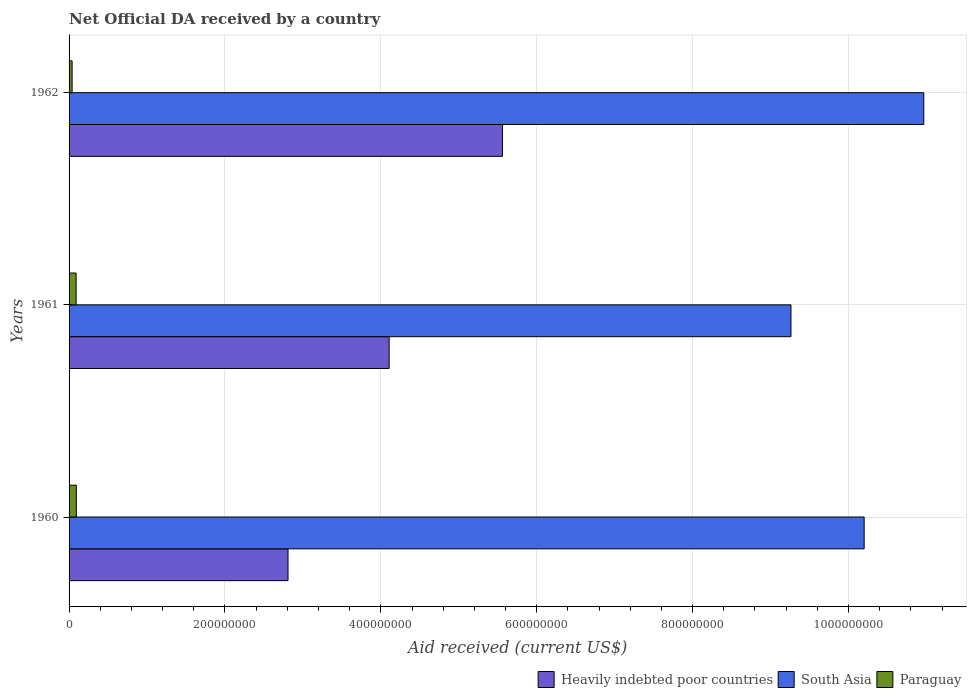How many groups of bars are there?
Offer a very short reply. 3. Are the number of bars per tick equal to the number of legend labels?
Make the answer very short. Yes. Are the number of bars on each tick of the Y-axis equal?
Provide a short and direct response. Yes. How many bars are there on the 3rd tick from the top?
Provide a succinct answer. 3. How many bars are there on the 1st tick from the bottom?
Keep it short and to the point. 3. In how many cases, is the number of bars for a given year not equal to the number of legend labels?
Offer a very short reply. 0. What is the net official development assistance aid received in Paraguay in 1961?
Provide a succinct answer. 9.07e+06. Across all years, what is the maximum net official development assistance aid received in Paraguay?
Make the answer very short. 9.32e+06. Across all years, what is the minimum net official development assistance aid received in South Asia?
Make the answer very short. 9.26e+08. In which year was the net official development assistance aid received in Heavily indebted poor countries maximum?
Your answer should be very brief. 1962. What is the total net official development assistance aid received in Heavily indebted poor countries in the graph?
Provide a short and direct response. 1.25e+09. What is the difference between the net official development assistance aid received in Paraguay in 1960 and that in 1962?
Provide a short and direct response. 5.43e+06. What is the difference between the net official development assistance aid received in Heavily indebted poor countries in 1961 and the net official development assistance aid received in South Asia in 1960?
Ensure brevity in your answer.  -6.09e+08. What is the average net official development assistance aid received in Heavily indebted poor countries per year?
Keep it short and to the point. 4.16e+08. In the year 1961, what is the difference between the net official development assistance aid received in Heavily indebted poor countries and net official development assistance aid received in South Asia?
Ensure brevity in your answer.  -5.16e+08. What is the ratio of the net official development assistance aid received in South Asia in 1960 to that in 1962?
Your response must be concise. 0.93. Is the net official development assistance aid received in Paraguay in 1960 less than that in 1961?
Provide a succinct answer. No. What is the difference between the highest and the second highest net official development assistance aid received in Heavily indebted poor countries?
Ensure brevity in your answer.  1.45e+08. What is the difference between the highest and the lowest net official development assistance aid received in South Asia?
Your answer should be very brief. 1.70e+08. In how many years, is the net official development assistance aid received in Paraguay greater than the average net official development assistance aid received in Paraguay taken over all years?
Ensure brevity in your answer.  2. What does the 1st bar from the bottom in 1961 represents?
Ensure brevity in your answer.  Heavily indebted poor countries. Is it the case that in every year, the sum of the net official development assistance aid received in Paraguay and net official development assistance aid received in Heavily indebted poor countries is greater than the net official development assistance aid received in South Asia?
Give a very brief answer. No. How many bars are there?
Provide a succinct answer. 9. Are the values on the major ticks of X-axis written in scientific E-notation?
Keep it short and to the point. No. Does the graph contain any zero values?
Your answer should be compact. No. What is the title of the graph?
Your response must be concise. Net Official DA received by a country. Does "St. Kitts and Nevis" appear as one of the legend labels in the graph?
Provide a succinct answer. No. What is the label or title of the X-axis?
Make the answer very short. Aid received (current US$). What is the Aid received (current US$) of Heavily indebted poor countries in 1960?
Your answer should be compact. 2.81e+08. What is the Aid received (current US$) in South Asia in 1960?
Provide a short and direct response. 1.02e+09. What is the Aid received (current US$) of Paraguay in 1960?
Make the answer very short. 9.32e+06. What is the Aid received (current US$) of Heavily indebted poor countries in 1961?
Your answer should be compact. 4.11e+08. What is the Aid received (current US$) of South Asia in 1961?
Offer a terse response. 9.26e+08. What is the Aid received (current US$) in Paraguay in 1961?
Your response must be concise. 9.07e+06. What is the Aid received (current US$) of Heavily indebted poor countries in 1962?
Your response must be concise. 5.56e+08. What is the Aid received (current US$) of South Asia in 1962?
Give a very brief answer. 1.10e+09. What is the Aid received (current US$) in Paraguay in 1962?
Provide a short and direct response. 3.89e+06. Across all years, what is the maximum Aid received (current US$) in Heavily indebted poor countries?
Your answer should be compact. 5.56e+08. Across all years, what is the maximum Aid received (current US$) of South Asia?
Your answer should be very brief. 1.10e+09. Across all years, what is the maximum Aid received (current US$) in Paraguay?
Your answer should be compact. 9.32e+06. Across all years, what is the minimum Aid received (current US$) of Heavily indebted poor countries?
Your response must be concise. 2.81e+08. Across all years, what is the minimum Aid received (current US$) in South Asia?
Your answer should be compact. 9.26e+08. Across all years, what is the minimum Aid received (current US$) in Paraguay?
Give a very brief answer. 3.89e+06. What is the total Aid received (current US$) in Heavily indebted poor countries in the graph?
Your answer should be compact. 1.25e+09. What is the total Aid received (current US$) of South Asia in the graph?
Keep it short and to the point. 3.04e+09. What is the total Aid received (current US$) in Paraguay in the graph?
Offer a very short reply. 2.23e+07. What is the difference between the Aid received (current US$) in Heavily indebted poor countries in 1960 and that in 1961?
Provide a succinct answer. -1.30e+08. What is the difference between the Aid received (current US$) in South Asia in 1960 and that in 1961?
Your answer should be compact. 9.39e+07. What is the difference between the Aid received (current US$) of Paraguay in 1960 and that in 1961?
Give a very brief answer. 2.50e+05. What is the difference between the Aid received (current US$) in Heavily indebted poor countries in 1960 and that in 1962?
Give a very brief answer. -2.75e+08. What is the difference between the Aid received (current US$) in South Asia in 1960 and that in 1962?
Give a very brief answer. -7.65e+07. What is the difference between the Aid received (current US$) of Paraguay in 1960 and that in 1962?
Give a very brief answer. 5.43e+06. What is the difference between the Aid received (current US$) in Heavily indebted poor countries in 1961 and that in 1962?
Your answer should be compact. -1.45e+08. What is the difference between the Aid received (current US$) of South Asia in 1961 and that in 1962?
Make the answer very short. -1.70e+08. What is the difference between the Aid received (current US$) of Paraguay in 1961 and that in 1962?
Provide a succinct answer. 5.18e+06. What is the difference between the Aid received (current US$) in Heavily indebted poor countries in 1960 and the Aid received (current US$) in South Asia in 1961?
Keep it short and to the point. -6.45e+08. What is the difference between the Aid received (current US$) in Heavily indebted poor countries in 1960 and the Aid received (current US$) in Paraguay in 1961?
Your answer should be very brief. 2.72e+08. What is the difference between the Aid received (current US$) in South Asia in 1960 and the Aid received (current US$) in Paraguay in 1961?
Your response must be concise. 1.01e+09. What is the difference between the Aid received (current US$) of Heavily indebted poor countries in 1960 and the Aid received (current US$) of South Asia in 1962?
Your response must be concise. -8.16e+08. What is the difference between the Aid received (current US$) in Heavily indebted poor countries in 1960 and the Aid received (current US$) in Paraguay in 1962?
Your answer should be very brief. 2.77e+08. What is the difference between the Aid received (current US$) of South Asia in 1960 and the Aid received (current US$) of Paraguay in 1962?
Give a very brief answer. 1.02e+09. What is the difference between the Aid received (current US$) in Heavily indebted poor countries in 1961 and the Aid received (current US$) in South Asia in 1962?
Ensure brevity in your answer.  -6.86e+08. What is the difference between the Aid received (current US$) in Heavily indebted poor countries in 1961 and the Aid received (current US$) in Paraguay in 1962?
Give a very brief answer. 4.07e+08. What is the difference between the Aid received (current US$) of South Asia in 1961 and the Aid received (current US$) of Paraguay in 1962?
Your answer should be compact. 9.22e+08. What is the average Aid received (current US$) in Heavily indebted poor countries per year?
Offer a terse response. 4.16e+08. What is the average Aid received (current US$) in South Asia per year?
Offer a very short reply. 1.01e+09. What is the average Aid received (current US$) in Paraguay per year?
Offer a very short reply. 7.43e+06. In the year 1960, what is the difference between the Aid received (current US$) in Heavily indebted poor countries and Aid received (current US$) in South Asia?
Make the answer very short. -7.39e+08. In the year 1960, what is the difference between the Aid received (current US$) of Heavily indebted poor countries and Aid received (current US$) of Paraguay?
Make the answer very short. 2.72e+08. In the year 1960, what is the difference between the Aid received (current US$) in South Asia and Aid received (current US$) in Paraguay?
Provide a succinct answer. 1.01e+09. In the year 1961, what is the difference between the Aid received (current US$) in Heavily indebted poor countries and Aid received (current US$) in South Asia?
Ensure brevity in your answer.  -5.16e+08. In the year 1961, what is the difference between the Aid received (current US$) in Heavily indebted poor countries and Aid received (current US$) in Paraguay?
Make the answer very short. 4.02e+08. In the year 1961, what is the difference between the Aid received (current US$) of South Asia and Aid received (current US$) of Paraguay?
Your answer should be very brief. 9.17e+08. In the year 1962, what is the difference between the Aid received (current US$) in Heavily indebted poor countries and Aid received (current US$) in South Asia?
Ensure brevity in your answer.  -5.41e+08. In the year 1962, what is the difference between the Aid received (current US$) in Heavily indebted poor countries and Aid received (current US$) in Paraguay?
Offer a very short reply. 5.52e+08. In the year 1962, what is the difference between the Aid received (current US$) in South Asia and Aid received (current US$) in Paraguay?
Your response must be concise. 1.09e+09. What is the ratio of the Aid received (current US$) of Heavily indebted poor countries in 1960 to that in 1961?
Offer a very short reply. 0.68. What is the ratio of the Aid received (current US$) of South Asia in 1960 to that in 1961?
Make the answer very short. 1.1. What is the ratio of the Aid received (current US$) of Paraguay in 1960 to that in 1961?
Ensure brevity in your answer.  1.03. What is the ratio of the Aid received (current US$) in Heavily indebted poor countries in 1960 to that in 1962?
Keep it short and to the point. 0.51. What is the ratio of the Aid received (current US$) of South Asia in 1960 to that in 1962?
Offer a very short reply. 0.93. What is the ratio of the Aid received (current US$) of Paraguay in 1960 to that in 1962?
Make the answer very short. 2.4. What is the ratio of the Aid received (current US$) of Heavily indebted poor countries in 1961 to that in 1962?
Keep it short and to the point. 0.74. What is the ratio of the Aid received (current US$) of South Asia in 1961 to that in 1962?
Offer a very short reply. 0.84. What is the ratio of the Aid received (current US$) in Paraguay in 1961 to that in 1962?
Your answer should be compact. 2.33. What is the difference between the highest and the second highest Aid received (current US$) of Heavily indebted poor countries?
Offer a terse response. 1.45e+08. What is the difference between the highest and the second highest Aid received (current US$) of South Asia?
Your response must be concise. 7.65e+07. What is the difference between the highest and the second highest Aid received (current US$) of Paraguay?
Keep it short and to the point. 2.50e+05. What is the difference between the highest and the lowest Aid received (current US$) of Heavily indebted poor countries?
Make the answer very short. 2.75e+08. What is the difference between the highest and the lowest Aid received (current US$) in South Asia?
Your answer should be compact. 1.70e+08. What is the difference between the highest and the lowest Aid received (current US$) of Paraguay?
Make the answer very short. 5.43e+06. 